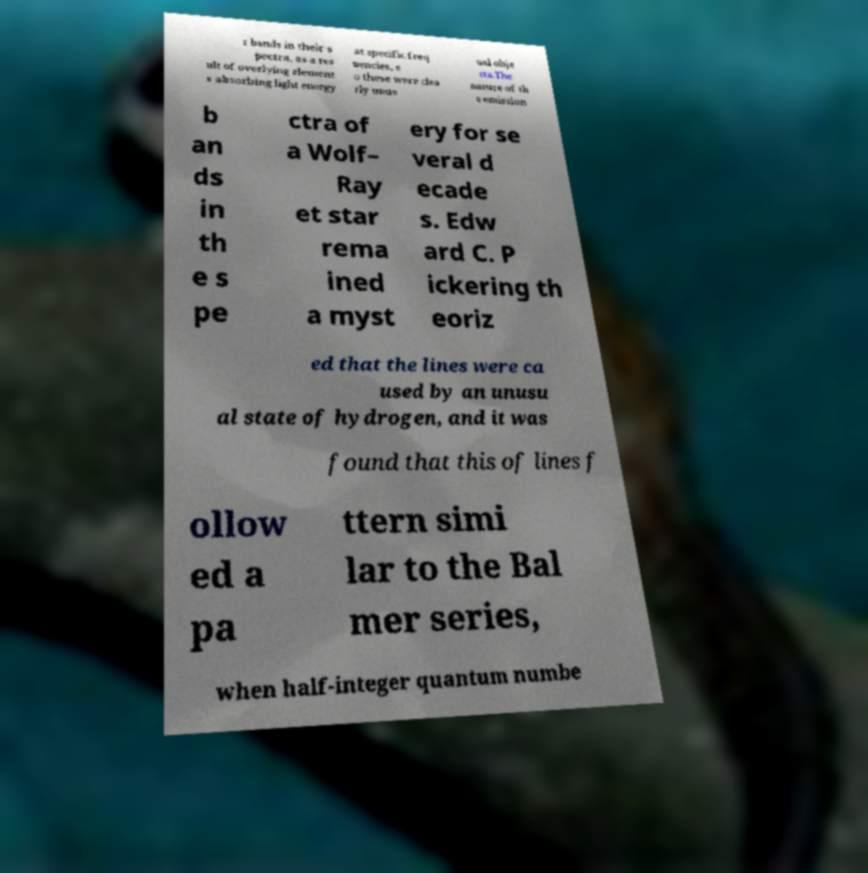There's text embedded in this image that I need extracted. Can you transcribe it verbatim? r bands in their s pectra, as a res ult of overlying element s absorbing light energy at specific freq uencies, s o these were clea rly unus ual obje cts.The nature of th e emission b an ds in th e s pe ctra of a Wolf– Ray et star rema ined a myst ery for se veral d ecade s. Edw ard C. P ickering th eoriz ed that the lines were ca used by an unusu al state of hydrogen, and it was found that this of lines f ollow ed a pa ttern simi lar to the Bal mer series, when half-integer quantum numbe 